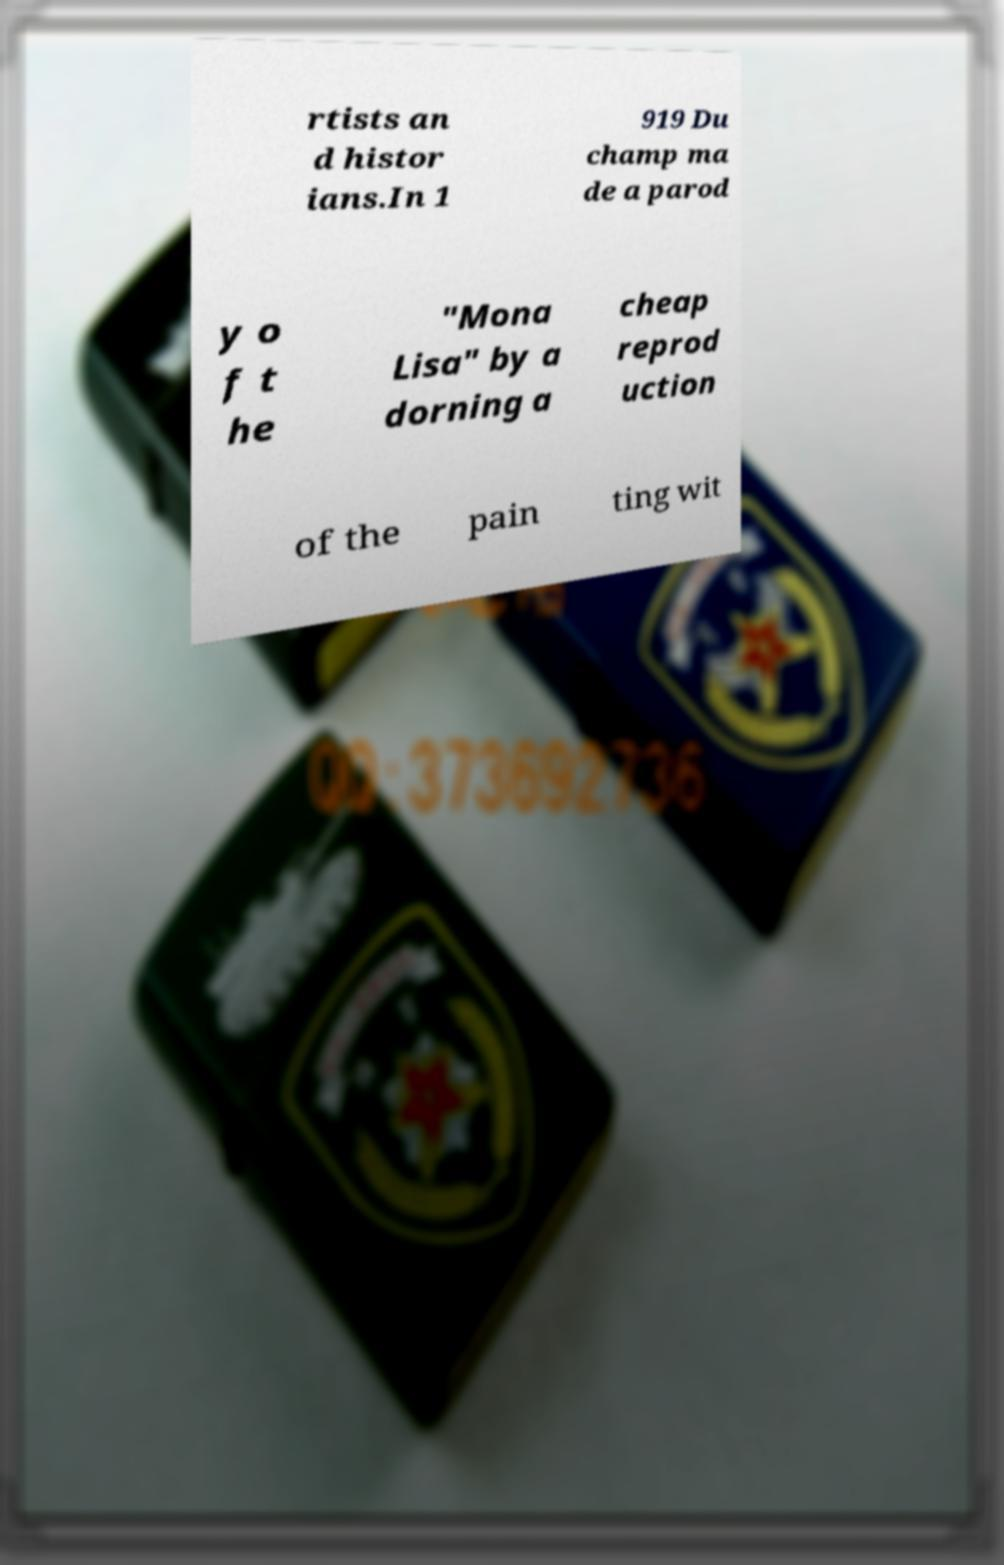There's text embedded in this image that I need extracted. Can you transcribe it verbatim? rtists an d histor ians.In 1 919 Du champ ma de a parod y o f t he "Mona Lisa" by a dorning a cheap reprod uction of the pain ting wit 